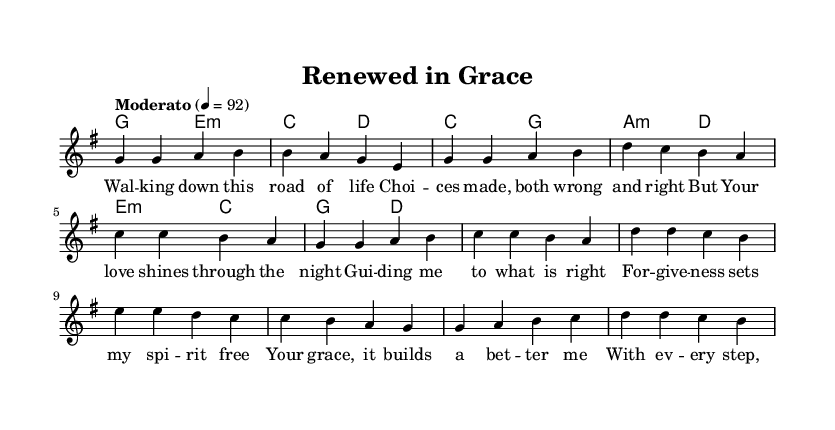What is the key signature of this music? The key signature is indicated at the beginning of the music and shows one sharp, which is characteristic of G major.
Answer: G major What is the time signature of this music? The time signature appears at the start of the piece, where it's written as 4/4, indicating four beats per measure.
Answer: 4/4 What is the tempo marking of this piece? The tempo marking is usually noted at the beginning or directly underneath the title. Here it states "Moderato" at 4 beats per minute.
Answer: Moderato How many measures are there in the verse section? By counting the number of measure bars in the melody section labeled as "Verse," we find there are four measures.
Answer: Four What is the emotion conveyed in the lyrics of the chorus? The lyrics focus on themes of forgiveness and personal growth, as described in the text that emphasizes spiritual liberation and self-discovery.
Answer: Forgiveness Which section comes after the verse? Observing the structure of the music, the flow alternates from verse to chorus. The chorus directly follows the verse, making it the next section.
Answer: Chorus What repeated theme is presented in the bridge? The bridge communicates the idea of growth and embracing change, emphasizing the importance of faith and hope in spiritual transformation.
Answer: Growing stronger 